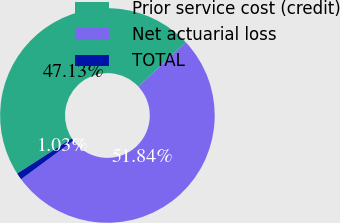<chart> <loc_0><loc_0><loc_500><loc_500><pie_chart><fcel>Prior service cost (credit)<fcel>Net actuarial loss<fcel>TOTAL<nl><fcel>47.13%<fcel>51.84%<fcel>1.03%<nl></chart> 